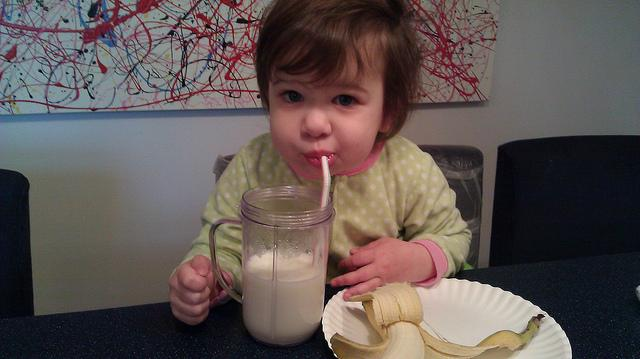What animal is known for eating the item on the plate? monkey 